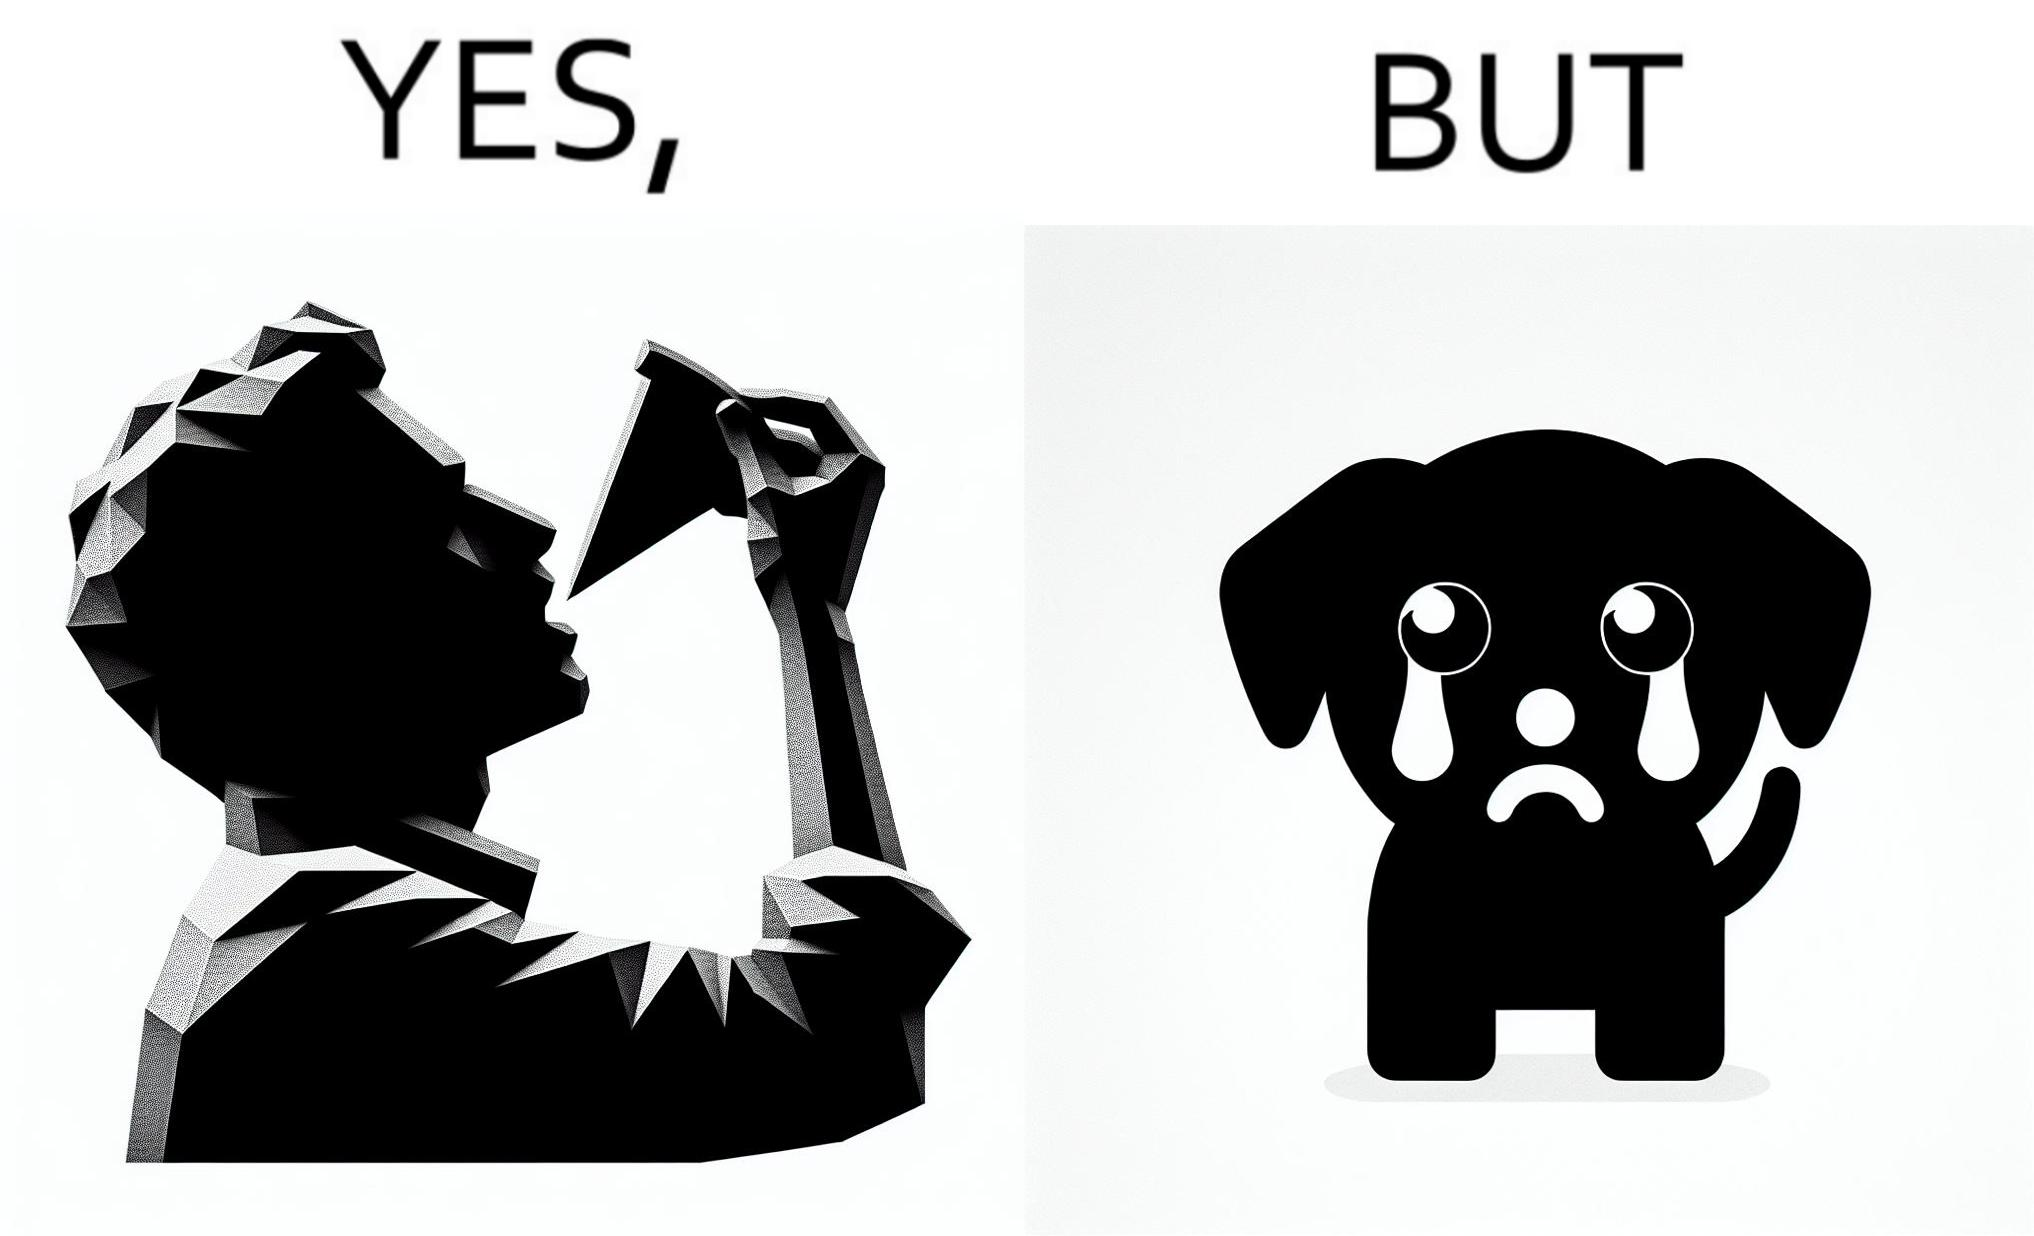Describe the contrast between the left and right parts of this image. In the left part of the image: It is a man eating a pizza In the right part of the image: It is a pet dog with teary eyes 